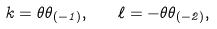Convert formula to latex. <formula><loc_0><loc_0><loc_500><loc_500>k = \theta \theta _ { ( - 1 ) } , \quad \ell = - \theta \theta _ { ( - 2 ) } ,</formula> 